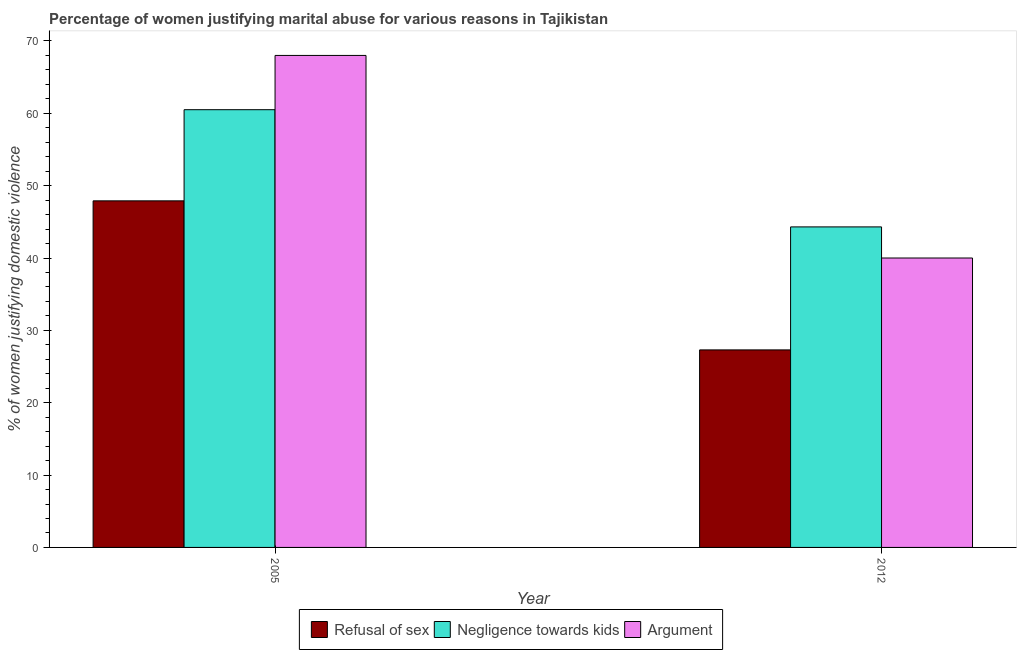Are the number of bars per tick equal to the number of legend labels?
Keep it short and to the point. Yes. Are the number of bars on each tick of the X-axis equal?
Ensure brevity in your answer.  Yes. How many bars are there on the 1st tick from the right?
Provide a short and direct response. 3. What is the label of the 1st group of bars from the left?
Your answer should be compact. 2005. What is the percentage of women justifying domestic violence due to refusal of sex in 2012?
Keep it short and to the point. 27.3. Across all years, what is the maximum percentage of women justifying domestic violence due to refusal of sex?
Your answer should be very brief. 47.9. Across all years, what is the minimum percentage of women justifying domestic violence due to negligence towards kids?
Offer a terse response. 44.3. In which year was the percentage of women justifying domestic violence due to refusal of sex maximum?
Keep it short and to the point. 2005. In which year was the percentage of women justifying domestic violence due to arguments minimum?
Provide a short and direct response. 2012. What is the total percentage of women justifying domestic violence due to refusal of sex in the graph?
Make the answer very short. 75.2. What is the difference between the percentage of women justifying domestic violence due to arguments in 2005 and that in 2012?
Give a very brief answer. 28. What is the difference between the percentage of women justifying domestic violence due to refusal of sex in 2005 and the percentage of women justifying domestic violence due to arguments in 2012?
Ensure brevity in your answer.  20.6. What is the average percentage of women justifying domestic violence due to negligence towards kids per year?
Ensure brevity in your answer.  52.4. What is the ratio of the percentage of women justifying domestic violence due to refusal of sex in 2005 to that in 2012?
Make the answer very short. 1.75. What does the 3rd bar from the left in 2005 represents?
Your answer should be very brief. Argument. What does the 2nd bar from the right in 2005 represents?
Make the answer very short. Negligence towards kids. How many bars are there?
Your answer should be very brief. 6. Are all the bars in the graph horizontal?
Your response must be concise. No. How many years are there in the graph?
Keep it short and to the point. 2. What is the difference between two consecutive major ticks on the Y-axis?
Your answer should be very brief. 10. Are the values on the major ticks of Y-axis written in scientific E-notation?
Give a very brief answer. No. Does the graph contain any zero values?
Provide a succinct answer. No. Does the graph contain grids?
Keep it short and to the point. No. How many legend labels are there?
Offer a terse response. 3. What is the title of the graph?
Provide a short and direct response. Percentage of women justifying marital abuse for various reasons in Tajikistan. What is the label or title of the Y-axis?
Keep it short and to the point. % of women justifying domestic violence. What is the % of women justifying domestic violence of Refusal of sex in 2005?
Provide a short and direct response. 47.9. What is the % of women justifying domestic violence of Negligence towards kids in 2005?
Give a very brief answer. 60.5. What is the % of women justifying domestic violence in Refusal of sex in 2012?
Provide a succinct answer. 27.3. What is the % of women justifying domestic violence in Negligence towards kids in 2012?
Keep it short and to the point. 44.3. Across all years, what is the maximum % of women justifying domestic violence of Refusal of sex?
Provide a short and direct response. 47.9. Across all years, what is the maximum % of women justifying domestic violence of Negligence towards kids?
Give a very brief answer. 60.5. Across all years, what is the maximum % of women justifying domestic violence in Argument?
Offer a terse response. 68. Across all years, what is the minimum % of women justifying domestic violence of Refusal of sex?
Ensure brevity in your answer.  27.3. Across all years, what is the minimum % of women justifying domestic violence in Negligence towards kids?
Your response must be concise. 44.3. What is the total % of women justifying domestic violence of Refusal of sex in the graph?
Your answer should be very brief. 75.2. What is the total % of women justifying domestic violence in Negligence towards kids in the graph?
Your response must be concise. 104.8. What is the total % of women justifying domestic violence in Argument in the graph?
Provide a succinct answer. 108. What is the difference between the % of women justifying domestic violence of Refusal of sex in 2005 and that in 2012?
Make the answer very short. 20.6. What is the difference between the % of women justifying domestic violence of Argument in 2005 and that in 2012?
Keep it short and to the point. 28. What is the difference between the % of women justifying domestic violence of Refusal of sex in 2005 and the % of women justifying domestic violence of Negligence towards kids in 2012?
Your response must be concise. 3.6. What is the average % of women justifying domestic violence of Refusal of sex per year?
Provide a short and direct response. 37.6. What is the average % of women justifying domestic violence in Negligence towards kids per year?
Keep it short and to the point. 52.4. What is the average % of women justifying domestic violence in Argument per year?
Keep it short and to the point. 54. In the year 2005, what is the difference between the % of women justifying domestic violence in Refusal of sex and % of women justifying domestic violence in Argument?
Your answer should be compact. -20.1. In the year 2012, what is the difference between the % of women justifying domestic violence in Negligence towards kids and % of women justifying domestic violence in Argument?
Your response must be concise. 4.3. What is the ratio of the % of women justifying domestic violence of Refusal of sex in 2005 to that in 2012?
Ensure brevity in your answer.  1.75. What is the ratio of the % of women justifying domestic violence in Negligence towards kids in 2005 to that in 2012?
Your response must be concise. 1.37. What is the ratio of the % of women justifying domestic violence in Argument in 2005 to that in 2012?
Your answer should be compact. 1.7. What is the difference between the highest and the second highest % of women justifying domestic violence of Refusal of sex?
Provide a succinct answer. 20.6. What is the difference between the highest and the second highest % of women justifying domestic violence in Argument?
Provide a succinct answer. 28. What is the difference between the highest and the lowest % of women justifying domestic violence of Refusal of sex?
Offer a very short reply. 20.6. What is the difference between the highest and the lowest % of women justifying domestic violence in Argument?
Your response must be concise. 28. 